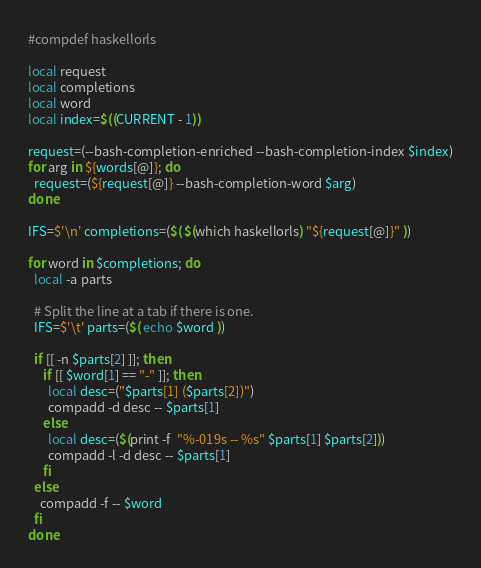Convert code to text. <code><loc_0><loc_0><loc_500><loc_500><_Bash_>#compdef haskellorls

local request
local completions
local word
local index=$((CURRENT - 1))

request=(--bash-completion-enriched --bash-completion-index $index)
for arg in ${words[@]}; do
  request=(${request[@]} --bash-completion-word $arg)
done

IFS=$'\n' completions=($( $(which haskellorls) "${request[@]}" ))

for word in $completions; do
  local -a parts

  # Split the line at a tab if there is one.
  IFS=$'\t' parts=($( echo $word ))

  if [[ -n $parts[2] ]]; then
     if [[ $word[1] == "-" ]]; then
       local desc=("$parts[1] ($parts[2])")
       compadd -d desc -- $parts[1]
     else
       local desc=($(print -f  "%-019s -- %s" $parts[1] $parts[2]))
       compadd -l -d desc -- $parts[1]
     fi
  else
    compadd -f -- $word
  fi
done
</code> 